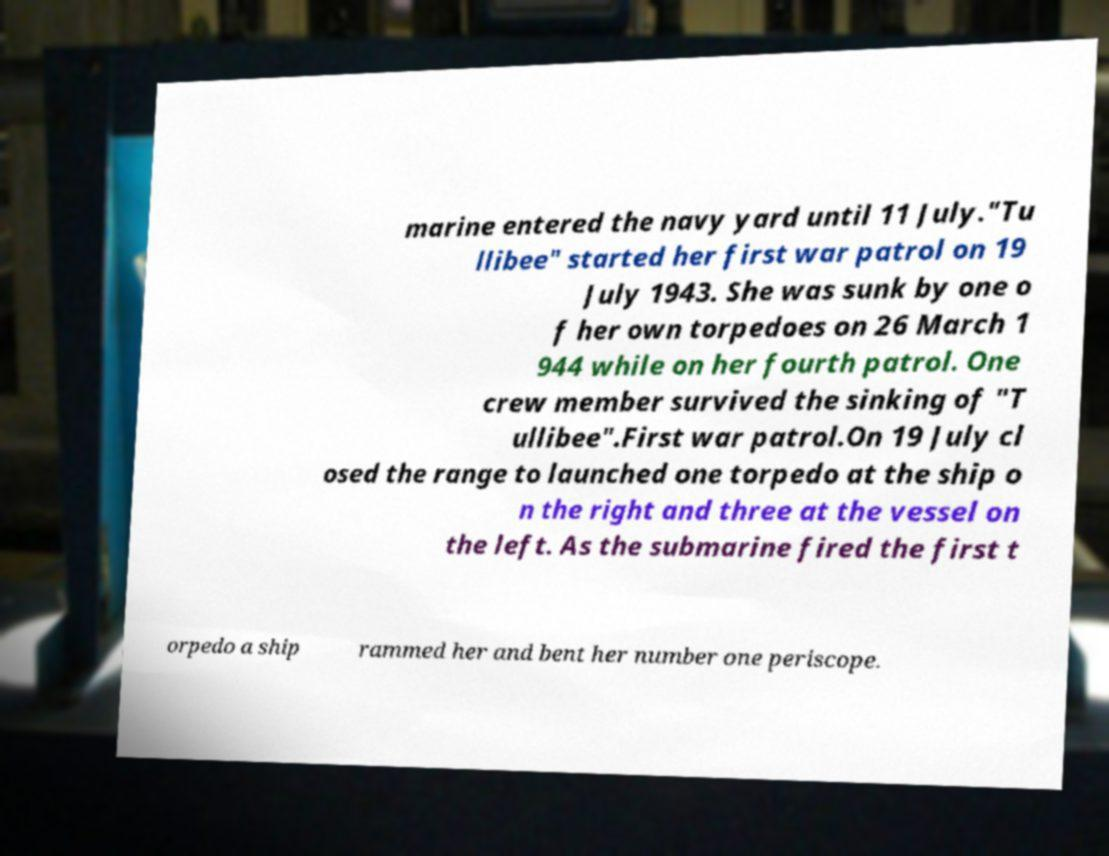Could you extract and type out the text from this image? marine entered the navy yard until 11 July."Tu llibee" started her first war patrol on 19 July 1943. She was sunk by one o f her own torpedoes on 26 March 1 944 while on her fourth patrol. One crew member survived the sinking of "T ullibee".First war patrol.On 19 July cl osed the range to launched one torpedo at the ship o n the right and three at the vessel on the left. As the submarine fired the first t orpedo a ship rammed her and bent her number one periscope. 